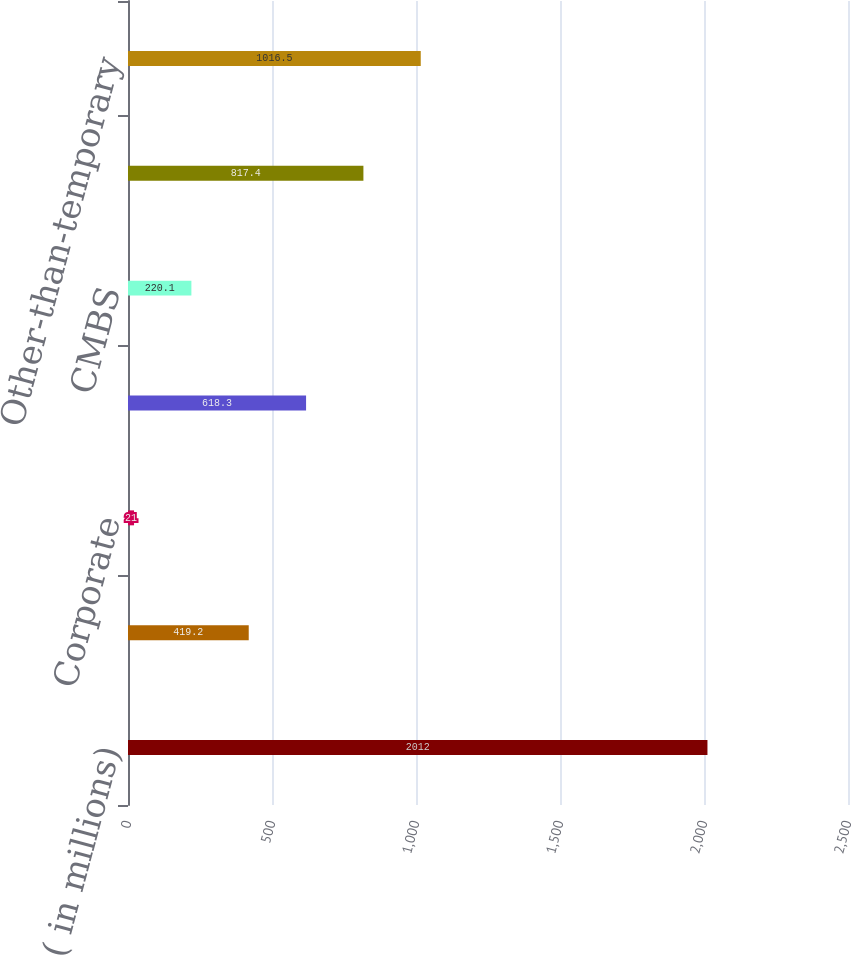Convert chart. <chart><loc_0><loc_0><loc_500><loc_500><bar_chart><fcel>( in millions)<fcel>Municipal<fcel>Corporate<fcel>RMBS<fcel>CMBS<fcel>Total fixed income securities<fcel>Other-than-temporary<nl><fcel>2012<fcel>419.2<fcel>21<fcel>618.3<fcel>220.1<fcel>817.4<fcel>1016.5<nl></chart> 